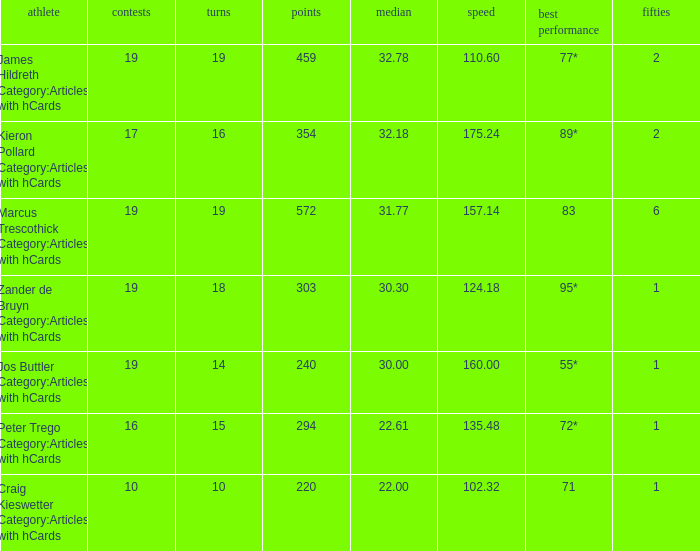How many innings for the player with an average of 22.61? 15.0. Help me parse the entirety of this table. {'header': ['athlete', 'contests', 'turns', 'points', 'median', 'speed', 'best performance', 'fifties'], 'rows': [['James Hildreth Category:Articles with hCards', '19', '19', '459', '32.78', '110.60', '77*', '2'], ['Kieron Pollard Category:Articles with hCards', '17', '16', '354', '32.18', '175.24', '89*', '2'], ['Marcus Trescothick Category:Articles with hCards', '19', '19', '572', '31.77', '157.14', '83', '6'], ['Zander de Bruyn Category:Articles with hCards', '19', '18', '303', '30.30', '124.18', '95*', '1'], ['Jos Buttler Category:Articles with hCards', '19', '14', '240', '30.00', '160.00', '55*', '1'], ['Peter Trego Category:Articles with hCards', '16', '15', '294', '22.61', '135.48', '72*', '1'], ['Craig Kieswetter Category:Articles with hCards', '10', '10', '220', '22.00', '102.32', '71', '1']]} 